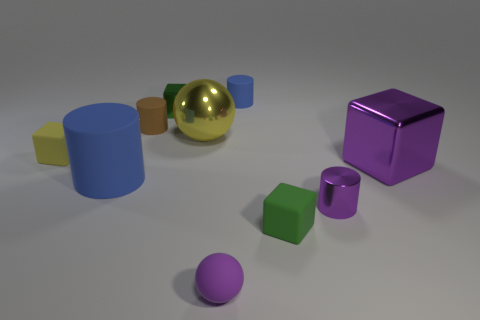Subtract 1 cubes. How many cubes are left? 3 Subtract all yellow cylinders. Subtract all brown spheres. How many cylinders are left? 4 Subtract all balls. How many objects are left? 8 Subtract 0 green spheres. How many objects are left? 10 Subtract all big purple metallic cubes. Subtract all large matte cylinders. How many objects are left? 8 Add 8 brown rubber things. How many brown rubber things are left? 9 Add 8 green balls. How many green balls exist? 8 